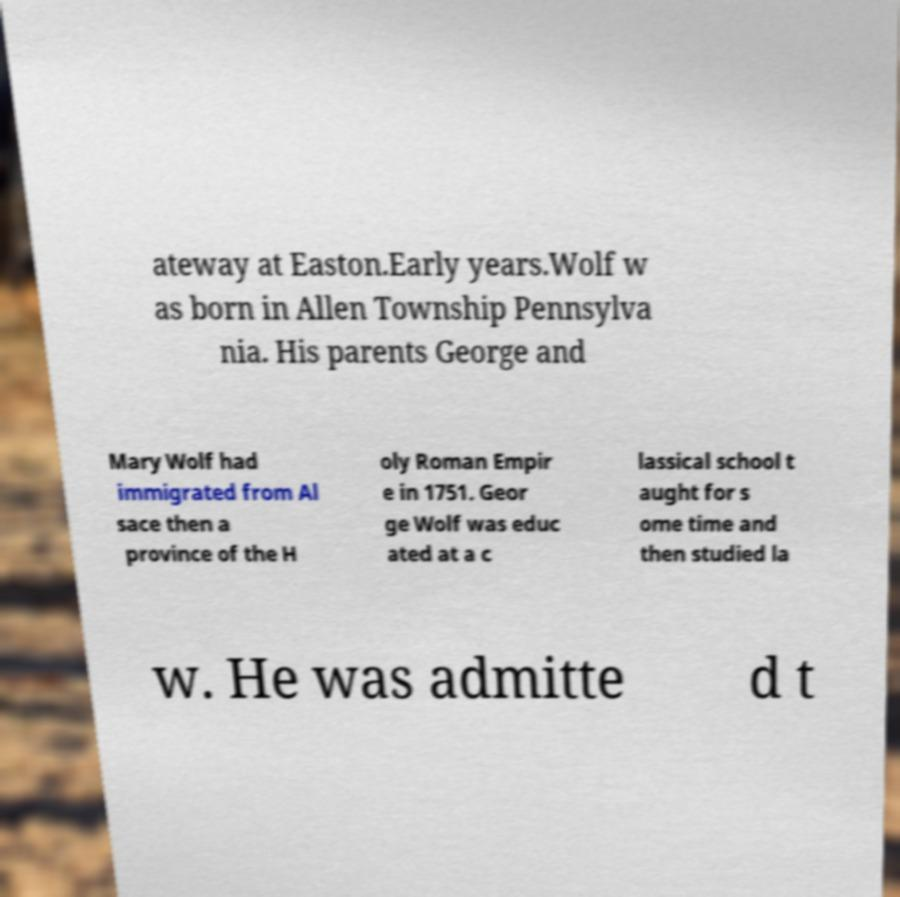Can you accurately transcribe the text from the provided image for me? ateway at Easton.Early years.Wolf w as born in Allen Township Pennsylva nia. His parents George and Mary Wolf had immigrated from Al sace then a province of the H oly Roman Empir e in 1751. Geor ge Wolf was educ ated at a c lassical school t aught for s ome time and then studied la w. He was admitte d t 